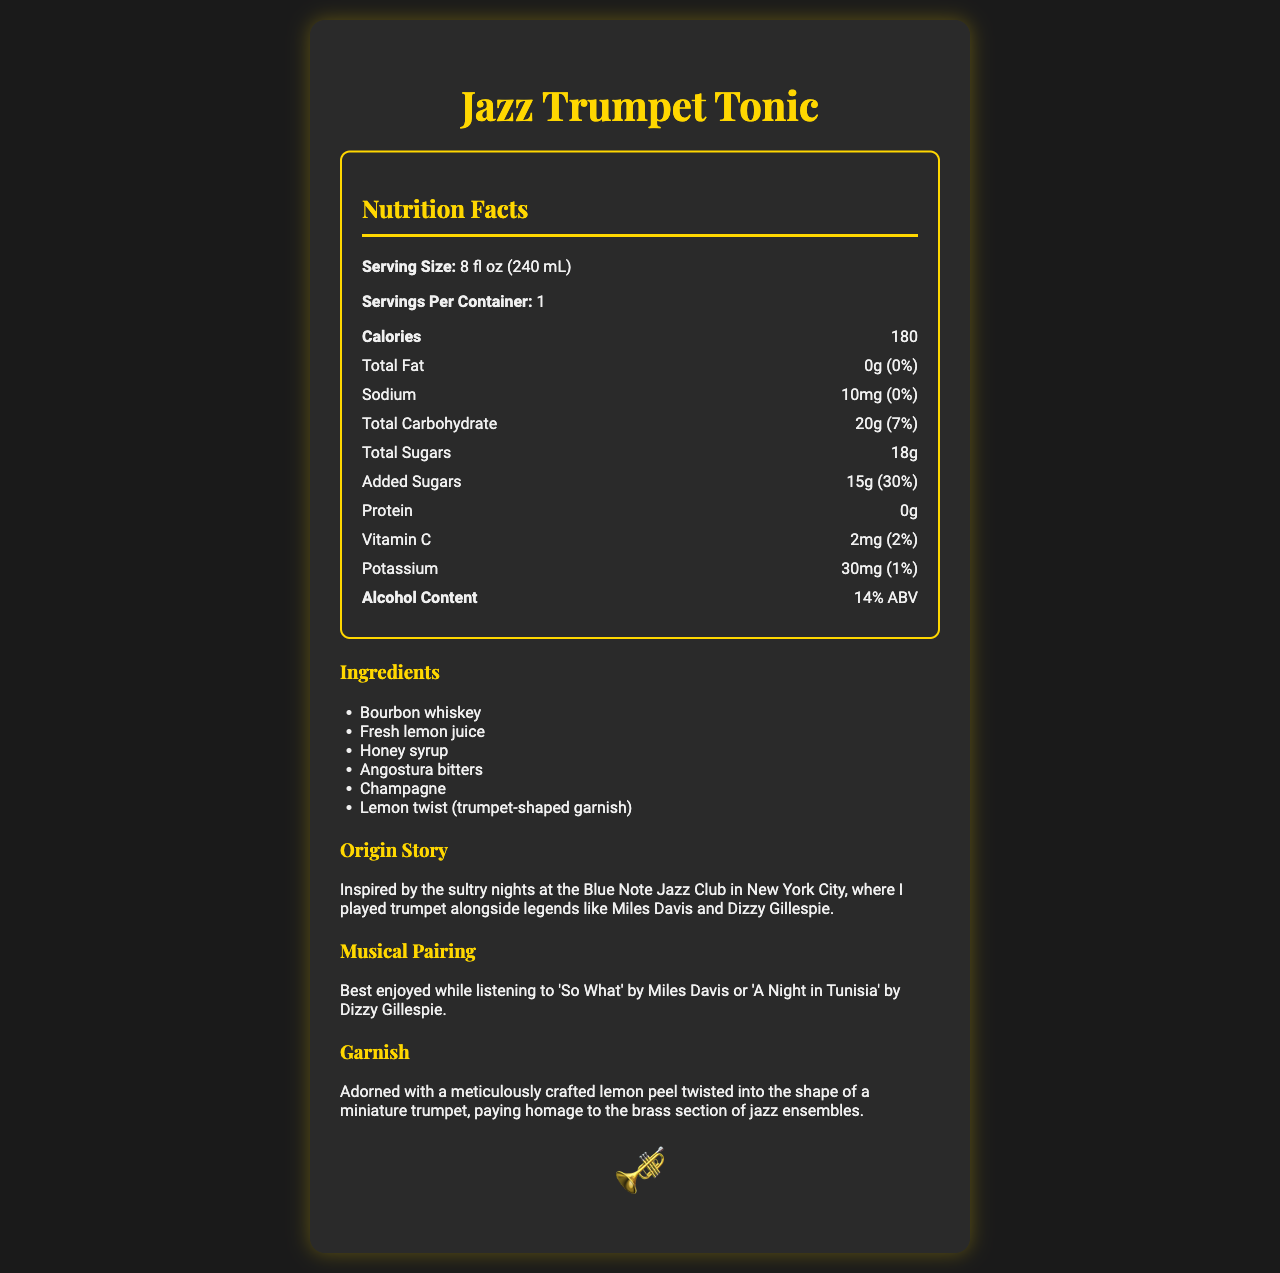what is the serving size of Jazz Trumpet Tonic? The serving size is mentioned at the top of the nutrition facts section as "Serving Size: 8 fl oz (240 mL)".
Answer: 8 fl oz (240 mL) how many calories are in one serving? The number of calories in one serving is listed as "Calories: 180" in the nutrition facts section.
Answer: 180 What is the total carbohydrate content per serving? The total carbohydrate content is listed as "Total Carbohydrate: 20g (7%)" in the nutrition facts section.
Answer: 20g (7%) Which ingredient is not part of the Jazz Trumpet Tonic? A. Bourbon whiskey B. Ginger beer C. Honey syrup D. Champagne Ginger beer is not listed as an ingredient in the ingredients section.
Answer: B Does the beverage contain any proteins? The protein content is listed as "Protein: 0g" in the nutrition facts section.
Answer: No How much added sugar is in each serving of the Jazz Trumpet Tonic? The added sugars content is listed as "Added Sugars: 15g (30%)" in the nutrition facts section.
Answer: 15g (30%) Are there any known allergens in this drink? The allergen information mentions "Contains no known allergens".
Answer: No What is the alcohol content of the Jazz Trumpet Tonic? The alcohol content is listed as "Alcohol Content: 14% ABV" in the nutrition facts section.
Answer: 14% ABV how much vitamin C does each serving provide? The Vitamin C content is listed as "Vitamin C: 2mg (2%)" in the nutrition facts section.
Answer: 2mg (2%) Which jazz club inspired the Jazz Trumpet Tonic? The origin story mentions "Inspired by the sultry nights at the Blue Note Jazz Club in New York City".
Answer: The Blue Note Jazz Club How many servings are there in one container? A. 2 B. 3 C. 1 D. 4 The nutrition facts section lists "Servings Per Container: 1".
Answer: C Is this beverage best enjoyed with jazz music? The musical pairing section suggests to enjoy it "while listening to 'So What' by Miles Davis or 'A Night in Tunisia' by Dizzy Gillespie".
Answer: Yes What is the main idea of the document? The document includes a detailed list of nutritional values, ingredients, origin story, musical pairing, and a description of the garnish, all related to the Jazz Trumpet Tonic.
Answer: The main idea is to provide the nutrition facts and additional information about the Jazz Trumpet Tonic, a signature cocktail inspired by jazz music and adorned with a trumpet-shaped lemon garnish. What day of the week is best to drink the Jazz Trumpet Tonic? There is no information about the best day of the week to drink the Jazz Trumpet Tonic in the document.
Answer: Cannot be determined 